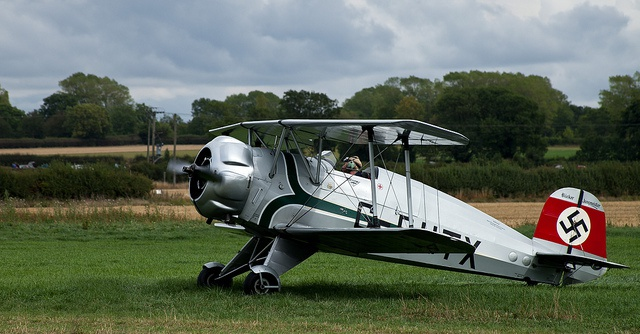Describe the objects in this image and their specific colors. I can see airplane in darkgray, black, lightgray, and gray tones and people in darkgray, black, and gray tones in this image. 